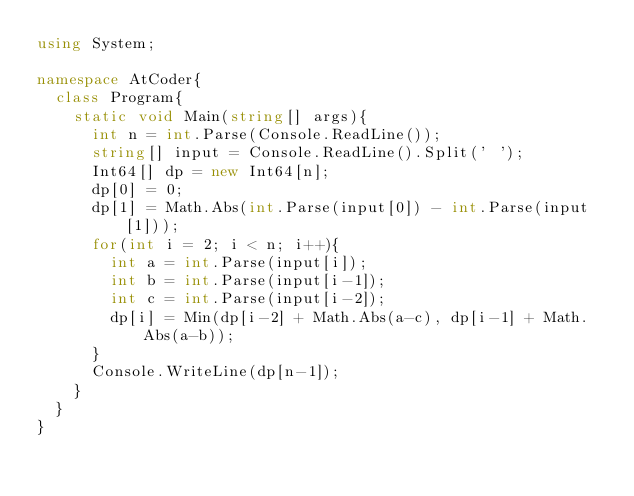<code> <loc_0><loc_0><loc_500><loc_500><_C#_>using System;

namespace AtCoder{
  class Program{
    static void Main(string[] args){
      int n = int.Parse(Console.ReadLine());
      string[] input = Console.ReadLine().Split(' ');
      Int64[] dp = new Int64[n];
      dp[0] = 0;
      dp[1] = Math.Abs(int.Parse(input[0]) - int.Parse(input[1]));
      for(int i = 2; i < n; i++){
        int a = int.Parse(input[i]);
        int b = int.Parse(input[i-1]);
        int c = int.Parse(input[i-2]);
        dp[i] = Min(dp[i-2] + Math.Abs(a-c), dp[i-1] + Math.Abs(a-b));
      }
      Console.WriteLine(dp[n-1]);
    }
  }
}
</code> 